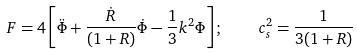Convert formula to latex. <formula><loc_0><loc_0><loc_500><loc_500>F = 4 \left [ \ddot { \Phi } + \frac { \dot { R } } { ( 1 + R ) } \dot { \Phi } - \frac { 1 } { 3 } k ^ { 2 } \Phi \right ] ; \quad c _ { s } ^ { 2 } = \frac { 1 } { 3 ( 1 + R ) }</formula> 